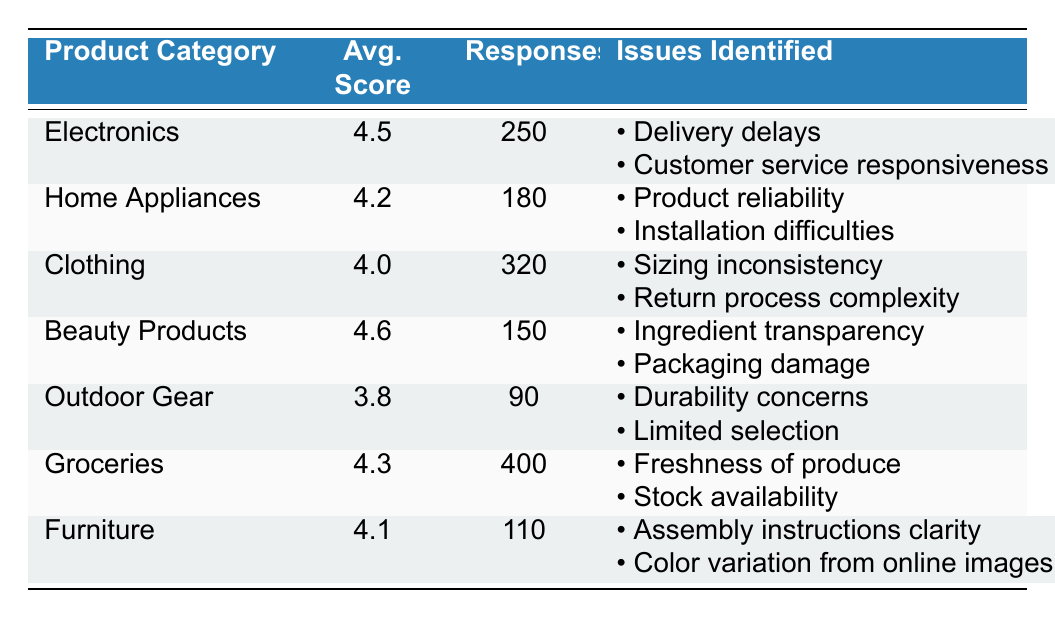What is the average customer satisfaction score for the Clothing category? The average score for the Clothing category is shown in the table, which is 4.0.
Answer: 4.0 Which product category has the highest average satisfaction score? By comparing the average scores in the table, Beauty Products has the highest score at 4.6.
Answer: Beauty Products How many responses were collected for the Electronics category? The table lists 250 responses for the Electronics category.
Answer: 250 What are the identified issues for Outdoor Gear? The table presents two issues for Outdoor Gear: durability concerns and limited selection.
Answer: Durability concerns, Limited selection What is the difference in average satisfaction scores between Beauty Products and Groceries? The average score for Beauty Products is 4.6 and Groceries is 4.3. The difference is 4.6 - 4.3 = 0.3.
Answer: 0.3 Is the average score for Home Appliances higher than that for Furniture? The average score for Home Appliances is 4.2 and for Furniture, it is 4.1. Since 4.2 is greater than 4.1, the answer is yes.
Answer: Yes What is the total number of responses across all product categories? Adding the number of responses from all categories: 250 + 180 + 320 + 150 + 90 + 400 + 110 = 1500.
Answer: 1500 Which product category includes issues related to the return process? The Clothing category has issues related to return process complexity as stated in the table.
Answer: Clothing What percentage of total responses does the Outdoor Gear category represent? The Outdoor Gear has 90 responses, and the total number of responses is 1500. Therefore, (90/1500) * 100 = 6%.
Answer: 6% How many identified issues are related to Customer service responsiveness? The identified issue of customer service responsiveness is only listed under Electronics, so there is one issue.
Answer: One issue What is the lowest average score among the product categories listed? The table indicates the lowest average score is for Outdoor Gear at 3.8.
Answer: 3.8 Which product categories have an average score below 4.2? The product categories with scores below 4.2 are Clothing (4.0) and Outdoor Gear (3.8).
Answer: Clothing, Outdoor Gear 